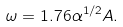Convert formula to latex. <formula><loc_0><loc_0><loc_500><loc_500>\omega = 1 . 7 6 \alpha ^ { 1 / 2 } A .</formula> 